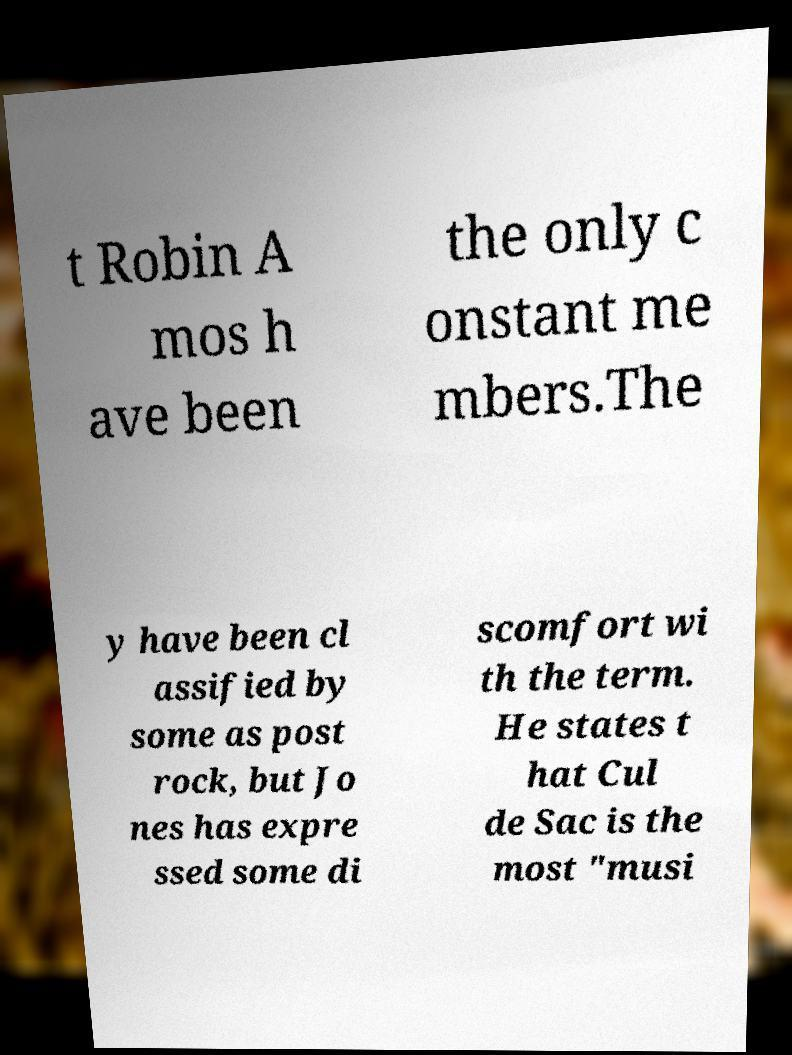Please read and relay the text visible in this image. What does it say? t Robin A mos h ave been the only c onstant me mbers.The y have been cl assified by some as post rock, but Jo nes has expre ssed some di scomfort wi th the term. He states t hat Cul de Sac is the most "musi 